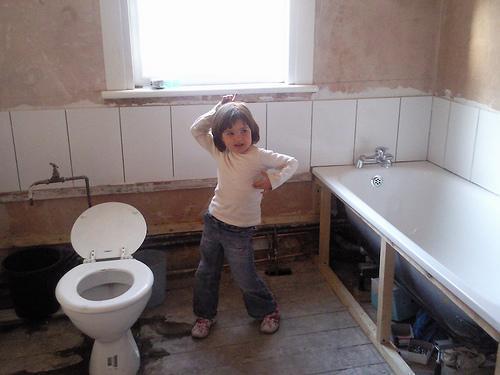How many people shown?
Give a very brief answer. 1. 